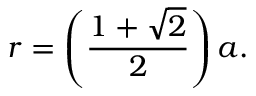<formula> <loc_0><loc_0><loc_500><loc_500>r = \left ( { \frac { 1 + { \sqrt { 2 } } } { 2 } } \right ) a .</formula> 